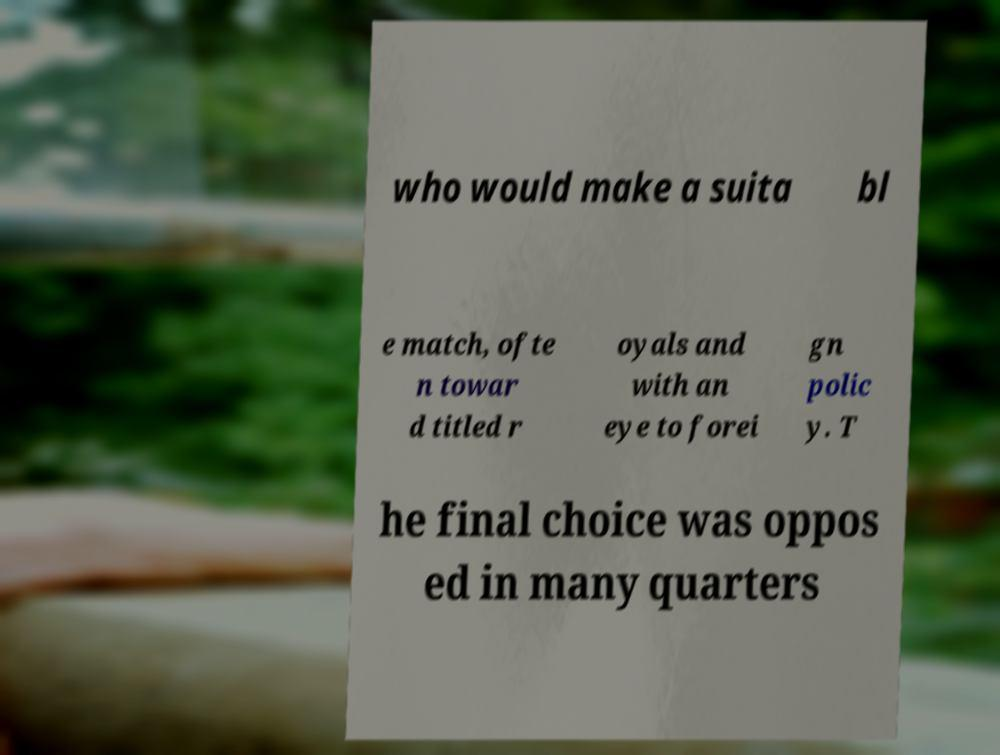Could you extract and type out the text from this image? who would make a suita bl e match, ofte n towar d titled r oyals and with an eye to forei gn polic y. T he final choice was oppos ed in many quarters 